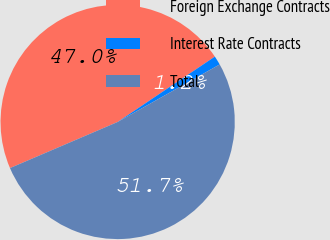Convert chart. <chart><loc_0><loc_0><loc_500><loc_500><pie_chart><fcel>Foreign Exchange Contracts<fcel>Interest Rate Contracts<fcel>Total<nl><fcel>47.02%<fcel>1.25%<fcel>51.73%<nl></chart> 